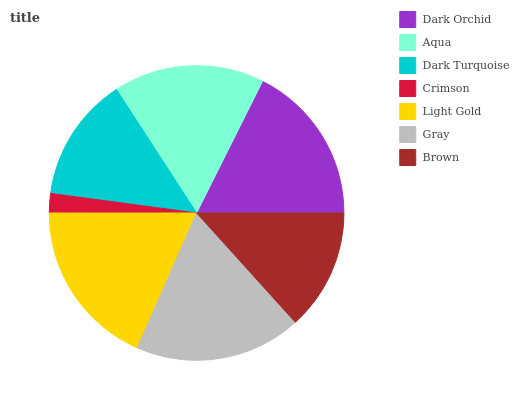Is Crimson the minimum?
Answer yes or no. Yes. Is Light Gold the maximum?
Answer yes or no. Yes. Is Aqua the minimum?
Answer yes or no. No. Is Aqua the maximum?
Answer yes or no. No. Is Dark Orchid greater than Aqua?
Answer yes or no. Yes. Is Aqua less than Dark Orchid?
Answer yes or no. Yes. Is Aqua greater than Dark Orchid?
Answer yes or no. No. Is Dark Orchid less than Aqua?
Answer yes or no. No. Is Aqua the high median?
Answer yes or no. Yes. Is Aqua the low median?
Answer yes or no. Yes. Is Brown the high median?
Answer yes or no. No. Is Dark Turquoise the low median?
Answer yes or no. No. 